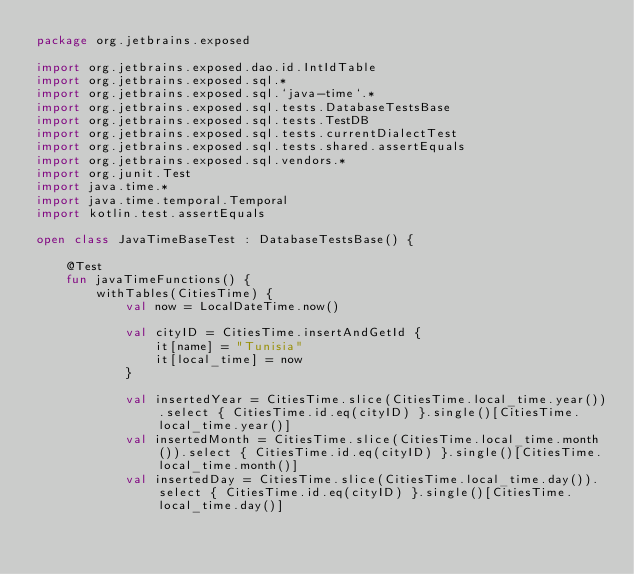<code> <loc_0><loc_0><loc_500><loc_500><_Kotlin_>package org.jetbrains.exposed

import org.jetbrains.exposed.dao.id.IntIdTable
import org.jetbrains.exposed.sql.*
import org.jetbrains.exposed.sql.`java-time`.*
import org.jetbrains.exposed.sql.tests.DatabaseTestsBase
import org.jetbrains.exposed.sql.tests.TestDB
import org.jetbrains.exposed.sql.tests.currentDialectTest
import org.jetbrains.exposed.sql.tests.shared.assertEquals
import org.jetbrains.exposed.sql.vendors.*
import org.junit.Test
import java.time.*
import java.time.temporal.Temporal
import kotlin.test.assertEquals

open class JavaTimeBaseTest : DatabaseTestsBase() {

    @Test
    fun javaTimeFunctions() {
        withTables(CitiesTime) {
            val now = LocalDateTime.now()

            val cityID = CitiesTime.insertAndGetId {
                it[name] = "Tunisia"
                it[local_time] = now
            }

            val insertedYear = CitiesTime.slice(CitiesTime.local_time.year()).select { CitiesTime.id.eq(cityID) }.single()[CitiesTime.local_time.year()]
            val insertedMonth = CitiesTime.slice(CitiesTime.local_time.month()).select { CitiesTime.id.eq(cityID) }.single()[CitiesTime.local_time.month()]
            val insertedDay = CitiesTime.slice(CitiesTime.local_time.day()).select { CitiesTime.id.eq(cityID) }.single()[CitiesTime.local_time.day()]</code> 